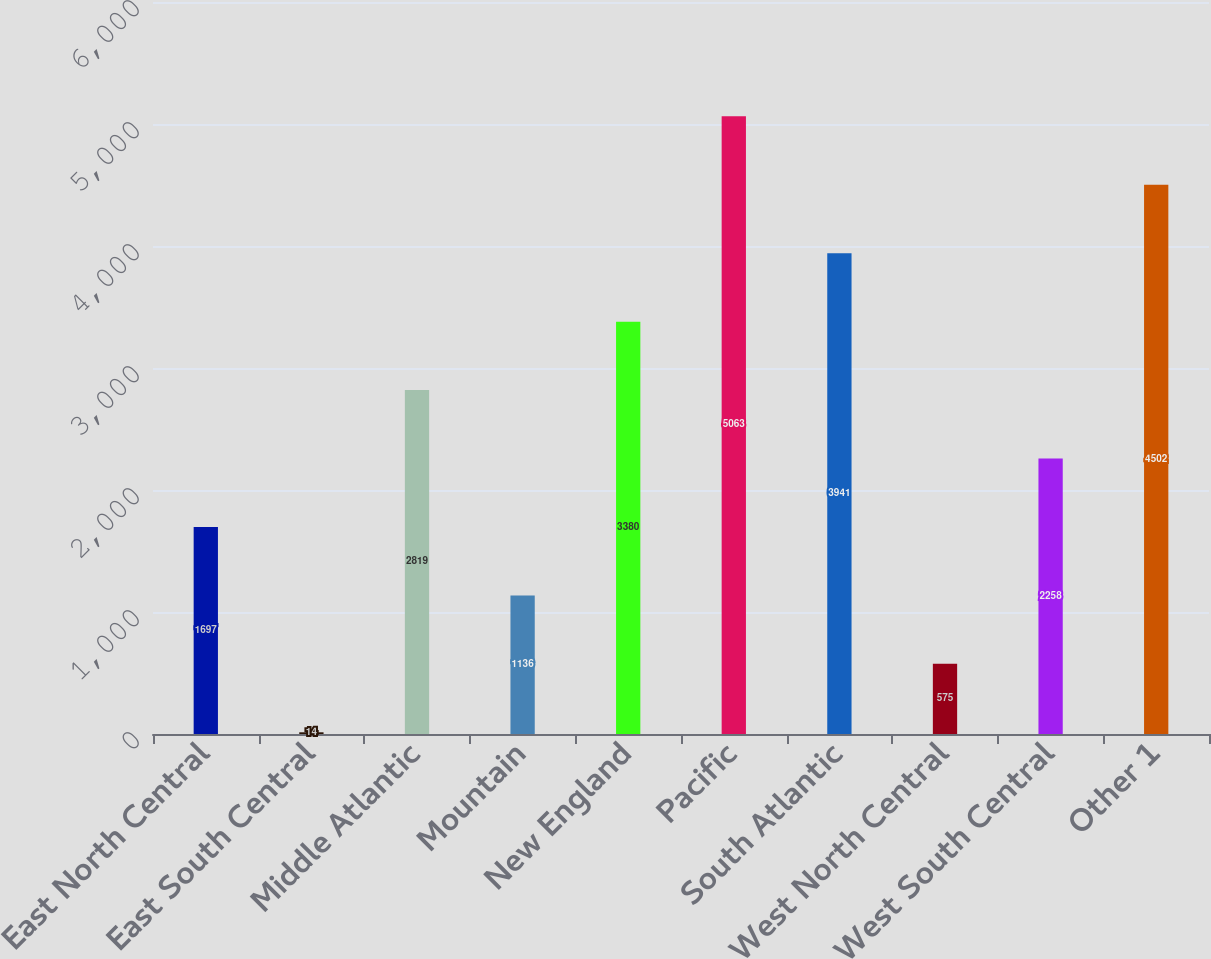<chart> <loc_0><loc_0><loc_500><loc_500><bar_chart><fcel>East North Central<fcel>East South Central<fcel>Middle Atlantic<fcel>Mountain<fcel>New England<fcel>Pacific<fcel>South Atlantic<fcel>West North Central<fcel>West South Central<fcel>Other 1<nl><fcel>1697<fcel>14<fcel>2819<fcel>1136<fcel>3380<fcel>5063<fcel>3941<fcel>575<fcel>2258<fcel>4502<nl></chart> 